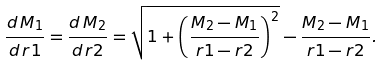<formula> <loc_0><loc_0><loc_500><loc_500>\frac { d \, M _ { 1 } } { d \, r 1 } = \frac { d \, M _ { 2 } } { d \, r 2 } = \sqrt { 1 + \left ( \frac { M _ { 2 } - M _ { 1 } } { r 1 - r 2 } \right ) ^ { 2 } } - \frac { M _ { 2 } - M _ { 1 } } { r 1 - r 2 } .</formula> 